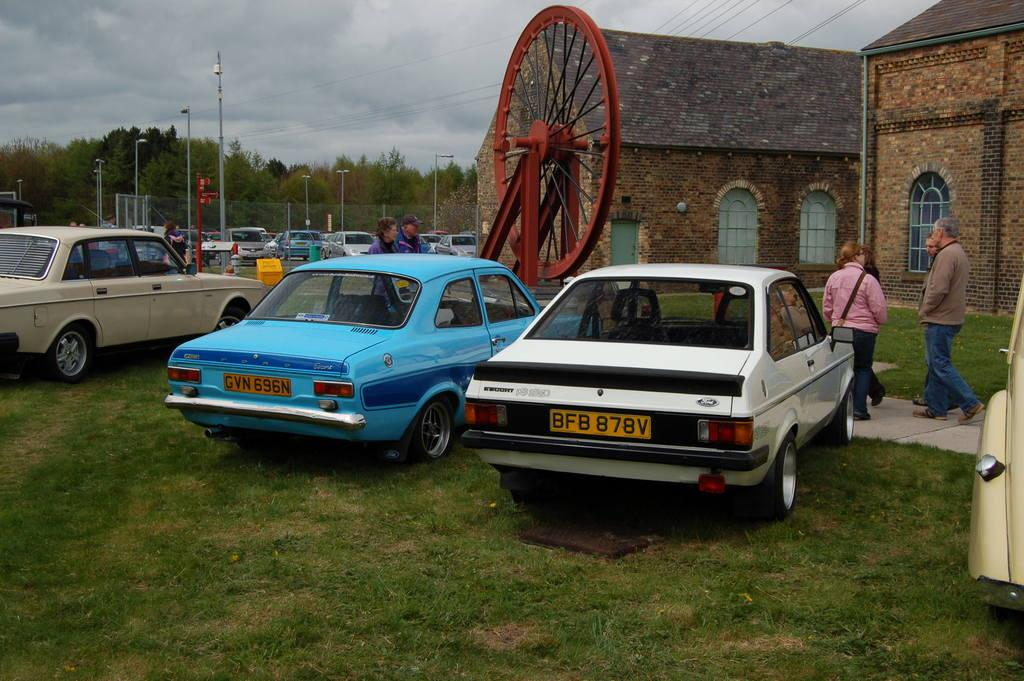What is the unusual location for the parked cars in the image? The cars are parked on the grass in the image. What are the people in the image doing? There are people walking on a walkway in the image. What type of natural elements can be seen in the image? There are trees in the image. What man-made structures are present in the image? There are poles and a fence in the image. How would you describe the weather in the image? The sky is cloudy in the image. What type of thread is being used to hold the family together in the image? There is no family or thread present in the image; it features cars parked on the grass, people walking on a walkway, trees, poles, a fence, and a cloudy sky. 